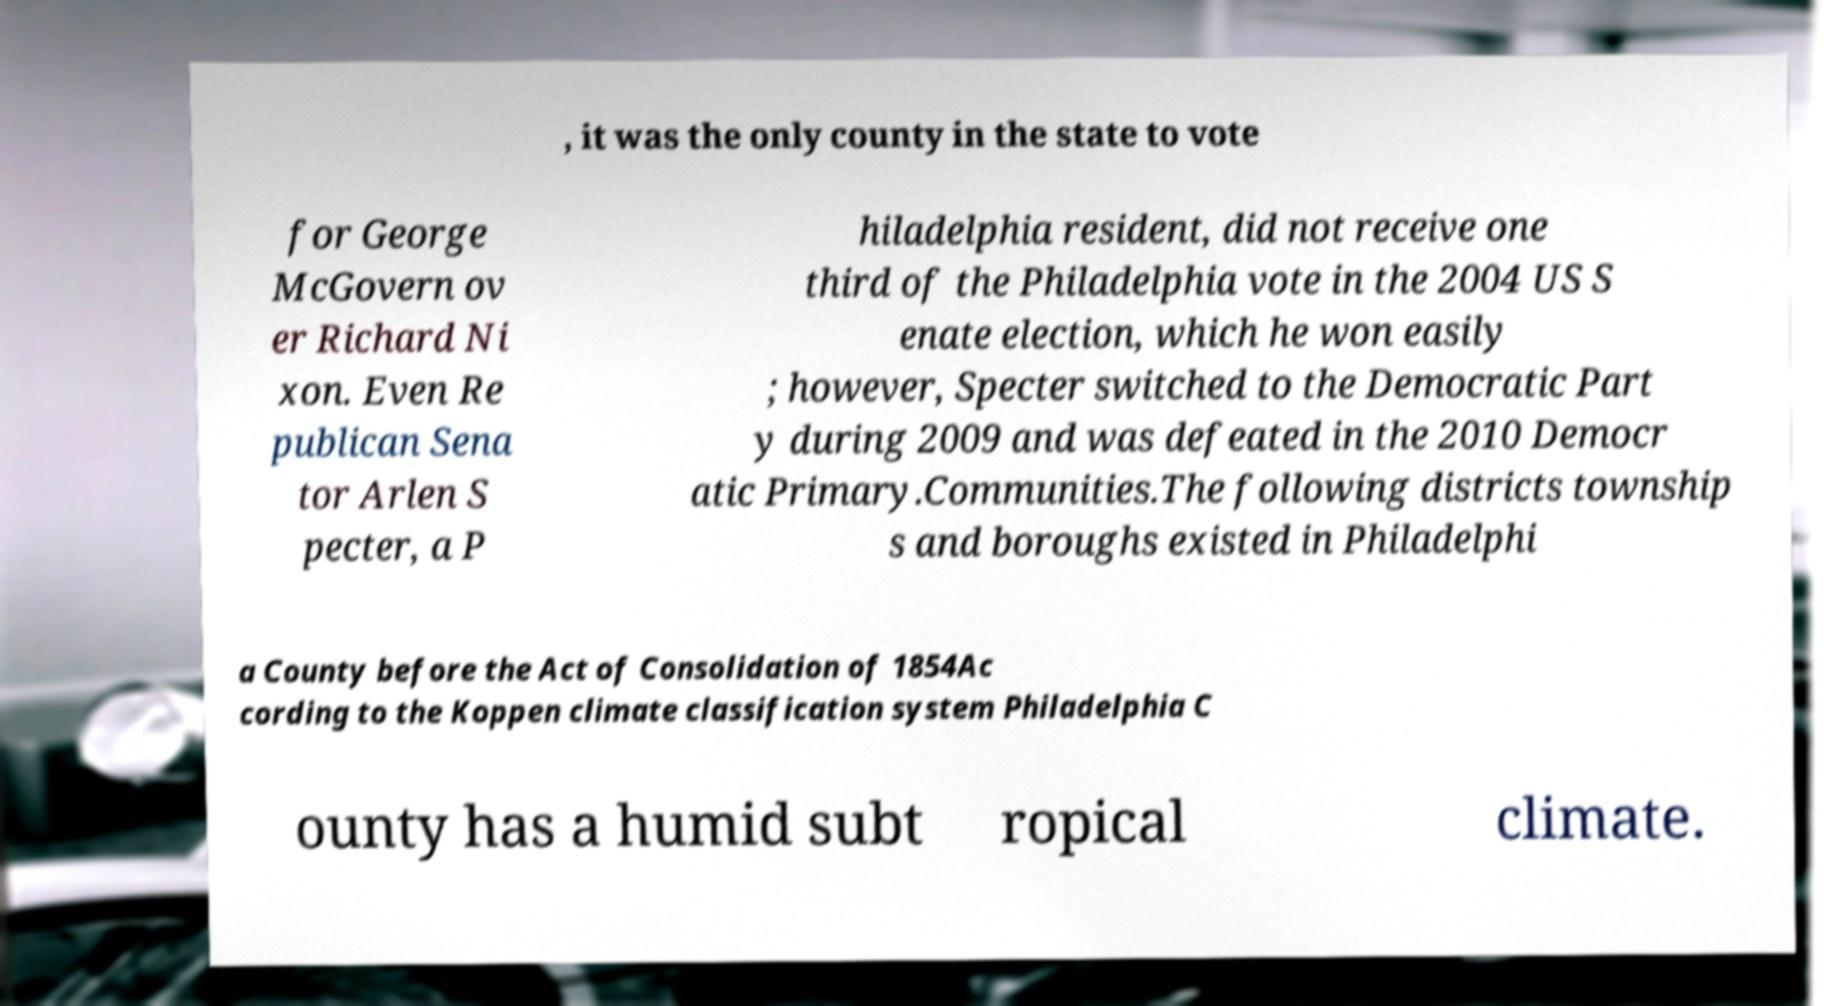Can you accurately transcribe the text from the provided image for me? , it was the only county in the state to vote for George McGovern ov er Richard Ni xon. Even Re publican Sena tor Arlen S pecter, a P hiladelphia resident, did not receive one third of the Philadelphia vote in the 2004 US S enate election, which he won easily ; however, Specter switched to the Democratic Part y during 2009 and was defeated in the 2010 Democr atic Primary.Communities.The following districts township s and boroughs existed in Philadelphi a County before the Act of Consolidation of 1854Ac cording to the Koppen climate classification system Philadelphia C ounty has a humid subt ropical climate. 